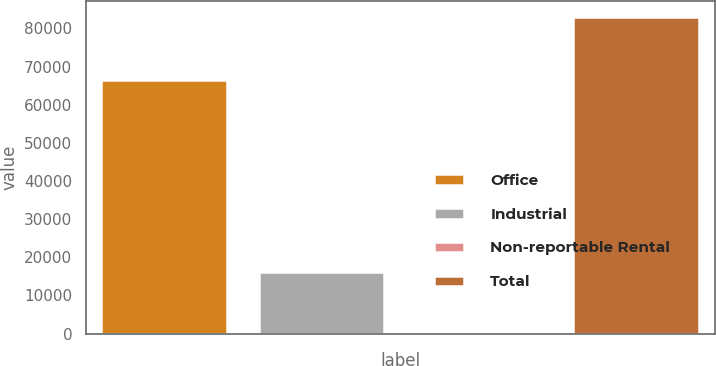Convert chart. <chart><loc_0><loc_0><loc_500><loc_500><bar_chart><fcel>Office<fcel>Industrial<fcel>Non-reportable Rental<fcel>Total<nl><fcel>66449<fcel>16210<fcel>341<fcel>83000<nl></chart> 